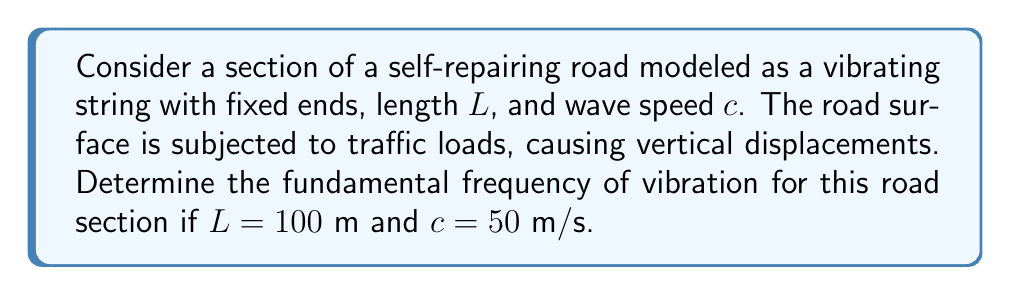Could you help me with this problem? To solve this problem, we'll use the wave equation and boundary conditions for a vibrating string with fixed ends:

1. The wave equation: $\frac{\partial^2 u}{\partial t^2} = c^2 \frac{\partial^2 u}{\partial x^2}$

2. Boundary conditions: $u(0,t) = u(L,t) = 0$

3. The general solution for the wave equation with these boundary conditions is:
   $u(x,t) = \sum_{n=1}^{\infty} A_n \sin(\frac{n\pi x}{L}) \cos(\frac{n\pi c t}{L})$

4. The frequency of each mode is given by:
   $f_n = \frac{n c}{2L}$

5. The fundamental frequency corresponds to $n=1$:
   $f_1 = \frac{c}{2L}$

6. Substituting the given values:
   $f_1 = \frac{50 \text{ m/s}}{2 \cdot 100 \text{ m}} = 0.25 \text{ Hz}$

Therefore, the fundamental frequency of vibration for this road section is 0.25 Hz.
Answer: 0.25 Hz 